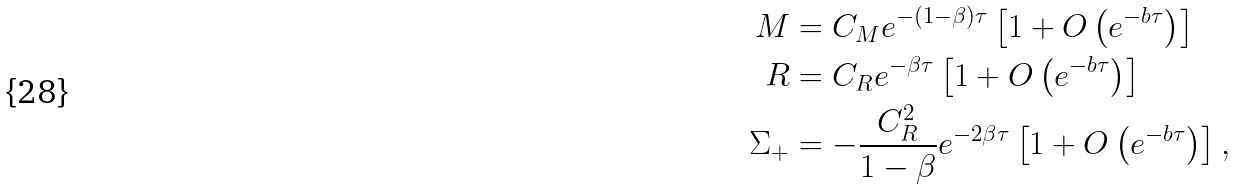Convert formula to latex. <formula><loc_0><loc_0><loc_500><loc_500>M & = C _ { M } e ^ { - ( 1 - \beta ) \tau } \left [ 1 + O \left ( e ^ { - b \tau } \right ) \right ] \\ R & = C _ { R } e ^ { - \beta \tau } \left [ 1 + O \left ( e ^ { - b \tau } \right ) \right ] \\ \Sigma _ { + } & = - \frac { C ^ { 2 } _ { R } } { 1 - \beta } e ^ { - 2 \beta \tau } \left [ 1 + O \left ( e ^ { - b \tau } \right ) \right ] ,</formula> 